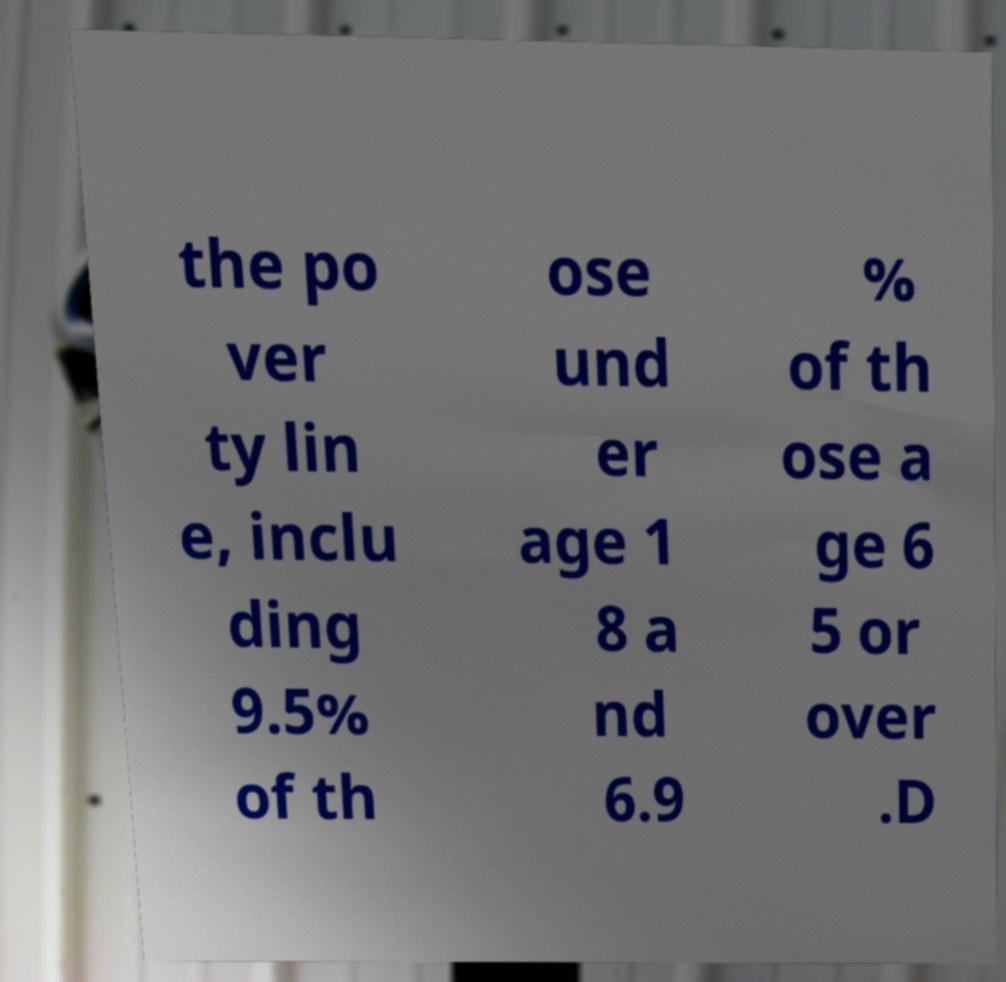I need the written content from this picture converted into text. Can you do that? the po ver ty lin e, inclu ding 9.5% of th ose und er age 1 8 a nd 6.9 % of th ose a ge 6 5 or over .D 